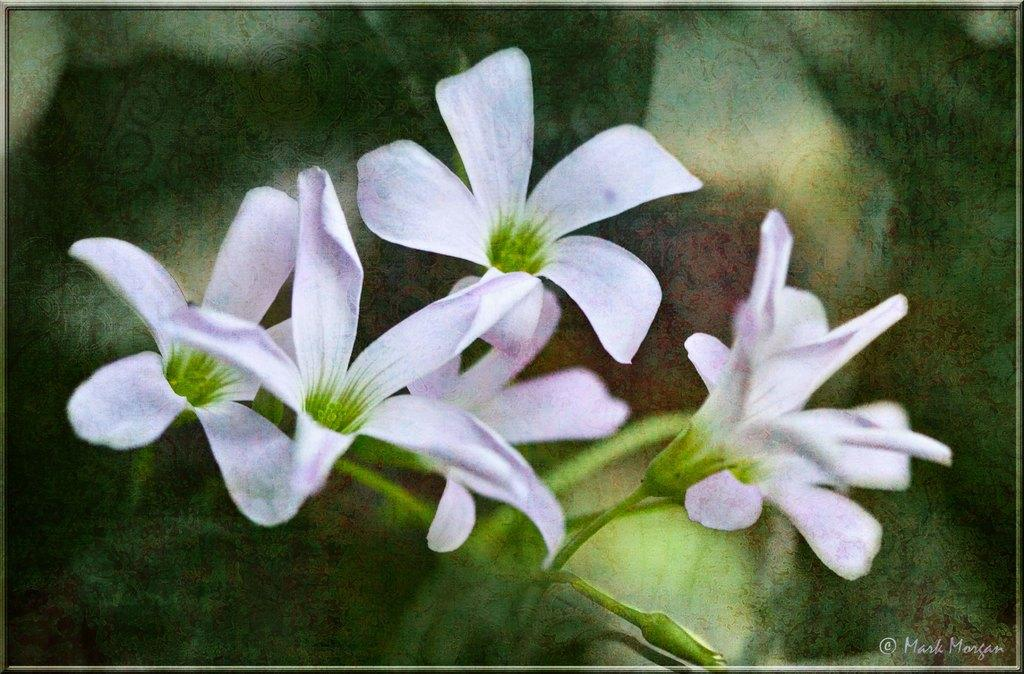What type of flowers are present in the image? There are white color flowers in the image. What type of plough is being used to harvest the flowers in the image? There is no plough present in the image, as it features only white color flowers. 